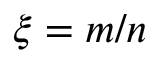Convert formula to latex. <formula><loc_0><loc_0><loc_500><loc_500>\xi = m / n</formula> 